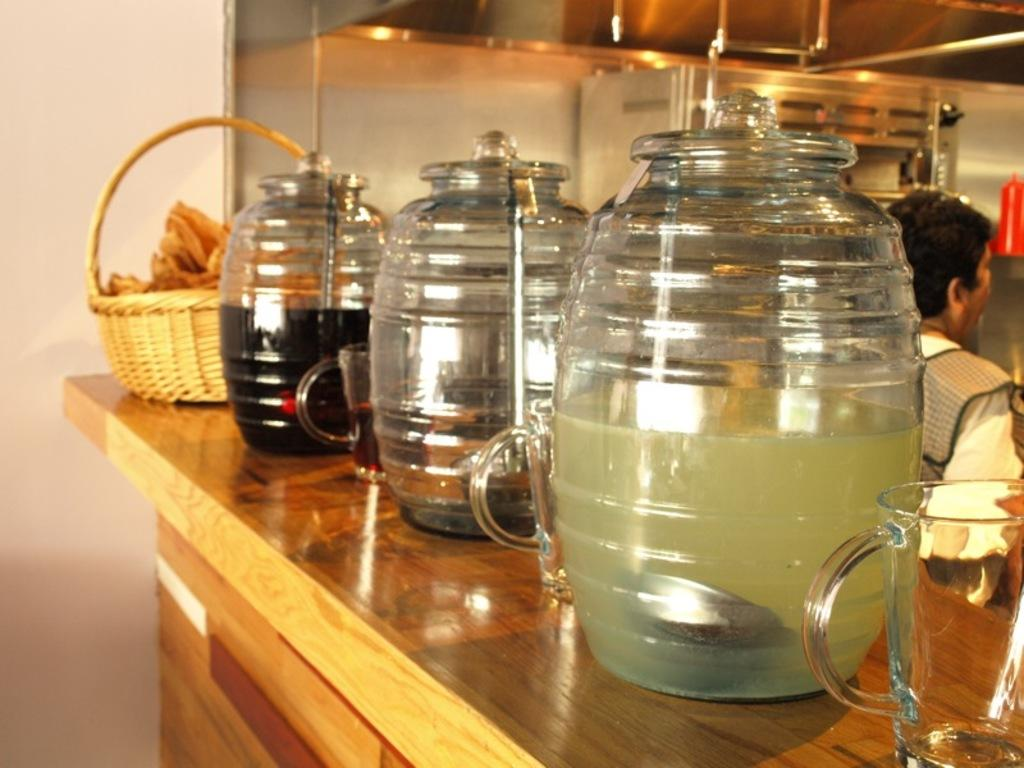What type of surface is visible in the image? There is a wooden platform in the image. What items can be seen on the wooden platform? There are glass jars with items, glasses, and a basket with items on the platform. Can you describe the person in the background of the image? Unfortunately, the provided facts do not give any information about the person in the background. What is visible in the background of the image? There is a wall in the background of the image. Where is the donkey playing in the image? There is no donkey present in the image. What type of clock is visible on the platform? There is no clock visible on the platform in the image. 